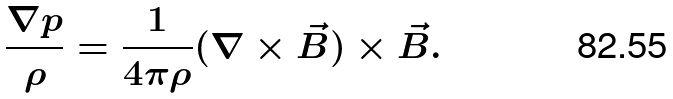Convert formula to latex. <formula><loc_0><loc_0><loc_500><loc_500>\frac { \nabla p } { \rho } = \frac { 1 } { 4 \pi \rho } ( \nabla \times \vec { B } ) \times \vec { B } .</formula> 